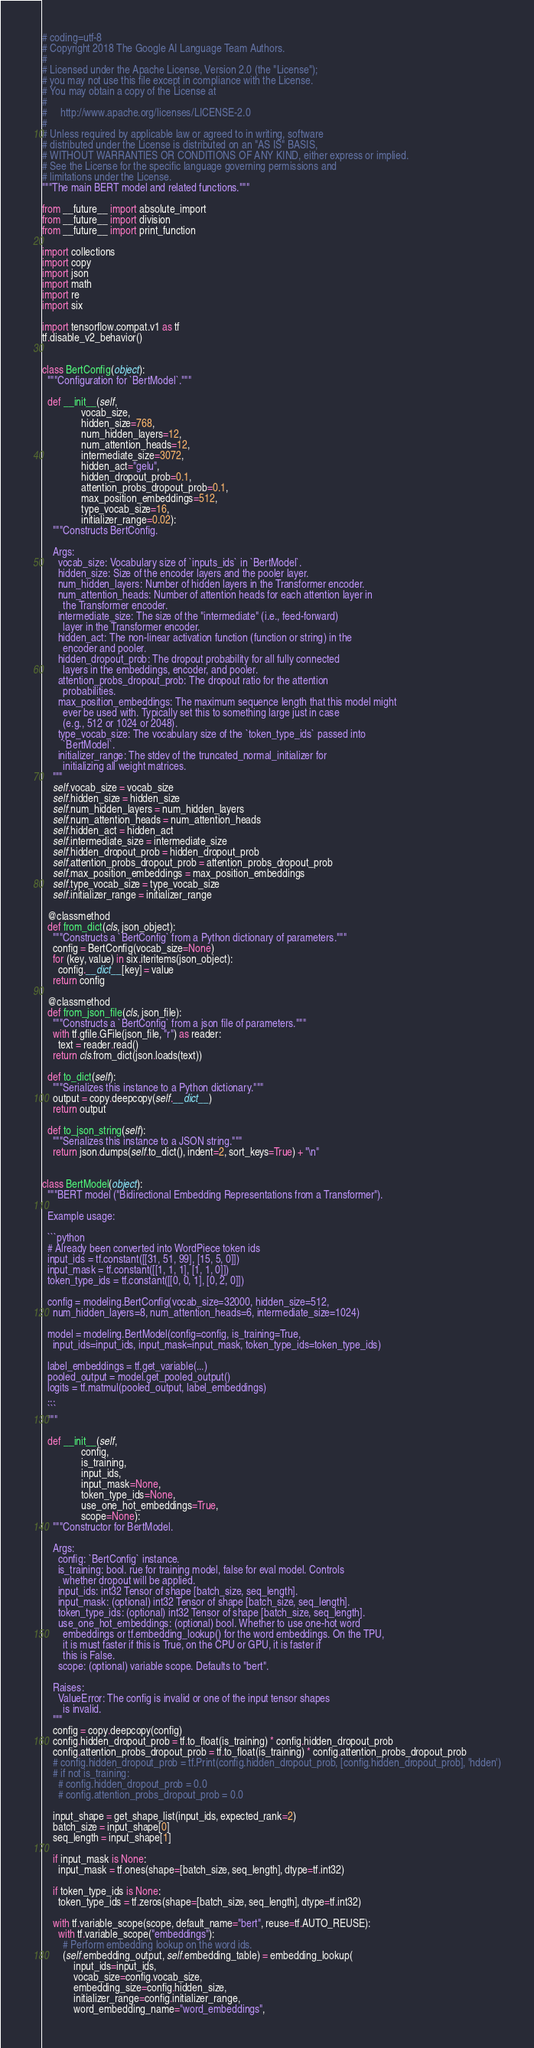Convert code to text. <code><loc_0><loc_0><loc_500><loc_500><_Python_># coding=utf-8
# Copyright 2018 The Google AI Language Team Authors.
#
# Licensed under the Apache License, Version 2.0 (the "License");
# you may not use this file except in compliance with the License.
# You may obtain a copy of the License at
#
#     http://www.apache.org/licenses/LICENSE-2.0
#
# Unless required by applicable law or agreed to in writing, software
# distributed under the License is distributed on an "AS IS" BASIS,
# WITHOUT WARRANTIES OR CONDITIONS OF ANY KIND, either express or implied.
# See the License for the specific language governing permissions and
# limitations under the License.
"""The main BERT model and related functions."""

from __future__ import absolute_import
from __future__ import division
from __future__ import print_function

import collections
import copy
import json
import math
import re
import six

import tensorflow.compat.v1 as tf
tf.disable_v2_behavior()


class BertConfig(object):
  """Configuration for `BertModel`."""

  def __init__(self,
               vocab_size,
               hidden_size=768,
               num_hidden_layers=12,
               num_attention_heads=12,
               intermediate_size=3072,
               hidden_act="gelu",
               hidden_dropout_prob=0.1,
               attention_probs_dropout_prob=0.1,
               max_position_embeddings=512,
               type_vocab_size=16,
               initializer_range=0.02):
    """Constructs BertConfig.

    Args:
      vocab_size: Vocabulary size of `inputs_ids` in `BertModel`.
      hidden_size: Size of the encoder layers and the pooler layer.
      num_hidden_layers: Number of hidden layers in the Transformer encoder.
      num_attention_heads: Number of attention heads for each attention layer in
        the Transformer encoder.
      intermediate_size: The size of the "intermediate" (i.e., feed-forward)
        layer in the Transformer encoder.
      hidden_act: The non-linear activation function (function or string) in the
        encoder and pooler.
      hidden_dropout_prob: The dropout probability for all fully connected
        layers in the embeddings, encoder, and pooler.
      attention_probs_dropout_prob: The dropout ratio for the attention
        probabilities.
      max_position_embeddings: The maximum sequence length that this model might
        ever be used with. Typically set this to something large just in case
        (e.g., 512 or 1024 or 2048).
      type_vocab_size: The vocabulary size of the `token_type_ids` passed into
        `BertModel`.
      initializer_range: The stdev of the truncated_normal_initializer for
        initializing all weight matrices.
    """
    self.vocab_size = vocab_size
    self.hidden_size = hidden_size
    self.num_hidden_layers = num_hidden_layers
    self.num_attention_heads = num_attention_heads
    self.hidden_act = hidden_act
    self.intermediate_size = intermediate_size
    self.hidden_dropout_prob = hidden_dropout_prob
    self.attention_probs_dropout_prob = attention_probs_dropout_prob
    self.max_position_embeddings = max_position_embeddings
    self.type_vocab_size = type_vocab_size
    self.initializer_range = initializer_range

  @classmethod
  def from_dict(cls, json_object):
    """Constructs a `BertConfig` from a Python dictionary of parameters."""
    config = BertConfig(vocab_size=None)
    for (key, value) in six.iteritems(json_object):
      config.__dict__[key] = value
    return config

  @classmethod
  def from_json_file(cls, json_file):
    """Constructs a `BertConfig` from a json file of parameters."""
    with tf.gfile.GFile(json_file, "r") as reader:
      text = reader.read()
    return cls.from_dict(json.loads(text))

  def to_dict(self):
    """Serializes this instance to a Python dictionary."""
    output = copy.deepcopy(self.__dict__)
    return output

  def to_json_string(self):
    """Serializes this instance to a JSON string."""
    return json.dumps(self.to_dict(), indent=2, sort_keys=True) + "\n"


class BertModel(object):
  """BERT model ("Bidirectional Embedding Representations from a Transformer").

  Example usage:

  ```python
  # Already been converted into WordPiece token ids
  input_ids = tf.constant([[31, 51, 99], [15, 5, 0]])
  input_mask = tf.constant([[1, 1, 1], [1, 1, 0]])
  token_type_ids = tf.constant([[0, 0, 1], [0, 2, 0]])

  config = modeling.BertConfig(vocab_size=32000, hidden_size=512,
    num_hidden_layers=8, num_attention_heads=6, intermediate_size=1024)

  model = modeling.BertModel(config=config, is_training=True,
    input_ids=input_ids, input_mask=input_mask, token_type_ids=token_type_ids)

  label_embeddings = tf.get_variable(...)
  pooled_output = model.get_pooled_output()
  logits = tf.matmul(pooled_output, label_embeddings)
  ...
  ```
  """

  def __init__(self,
               config,
               is_training,
               input_ids,
               input_mask=None,
               token_type_ids=None,
               use_one_hot_embeddings=True,
               scope=None):
    """Constructor for BertModel.

    Args:
      config: `BertConfig` instance.
      is_training: bool. rue for training model, false for eval model. Controls
        whether dropout will be applied.
      input_ids: int32 Tensor of shape [batch_size, seq_length].
      input_mask: (optional) int32 Tensor of shape [batch_size, seq_length].
      token_type_ids: (optional) int32 Tensor of shape [batch_size, seq_length].
      use_one_hot_embeddings: (optional) bool. Whether to use one-hot word
        embeddings or tf.embedding_lookup() for the word embeddings. On the TPU,
        it is must faster if this is True, on the CPU or GPU, it is faster if
        this is False.
      scope: (optional) variable scope. Defaults to "bert".

    Raises:
      ValueError: The config is invalid or one of the input tensor shapes
        is invalid.
    """
    config = copy.deepcopy(config)
    config.hidden_dropout_prob = tf.to_float(is_training) * config.hidden_dropout_prob
    config.attention_probs_dropout_prob = tf.to_float(is_training) * config.attention_probs_dropout_prob
    # config.hidden_dropout_prob = tf.Print(config.hidden_dropout_prob, [config.hidden_dropout_prob], 'hdden')
    # if not is_training:
      # config.hidden_dropout_prob = 0.0
      # config.attention_probs_dropout_prob = 0.0

    input_shape = get_shape_list(input_ids, expected_rank=2)
    batch_size = input_shape[0]
    seq_length = input_shape[1]

    if input_mask is None:
      input_mask = tf.ones(shape=[batch_size, seq_length], dtype=tf.int32)

    if token_type_ids is None:
      token_type_ids = tf.zeros(shape=[batch_size, seq_length], dtype=tf.int32)

    with tf.variable_scope(scope, default_name="bert", reuse=tf.AUTO_REUSE):
      with tf.variable_scope("embeddings"):
        # Perform embedding lookup on the word ids.
        (self.embedding_output, self.embedding_table) = embedding_lookup(
            input_ids=input_ids,
            vocab_size=config.vocab_size,
            embedding_size=config.hidden_size,
            initializer_range=config.initializer_range,
            word_embedding_name="word_embeddings",</code> 